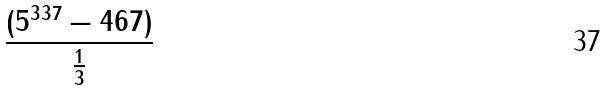Convert formula to latex. <formula><loc_0><loc_0><loc_500><loc_500>\frac { ( 5 ^ { 3 3 7 } - 4 6 7 ) } { \frac { 1 } { 3 } }</formula> 